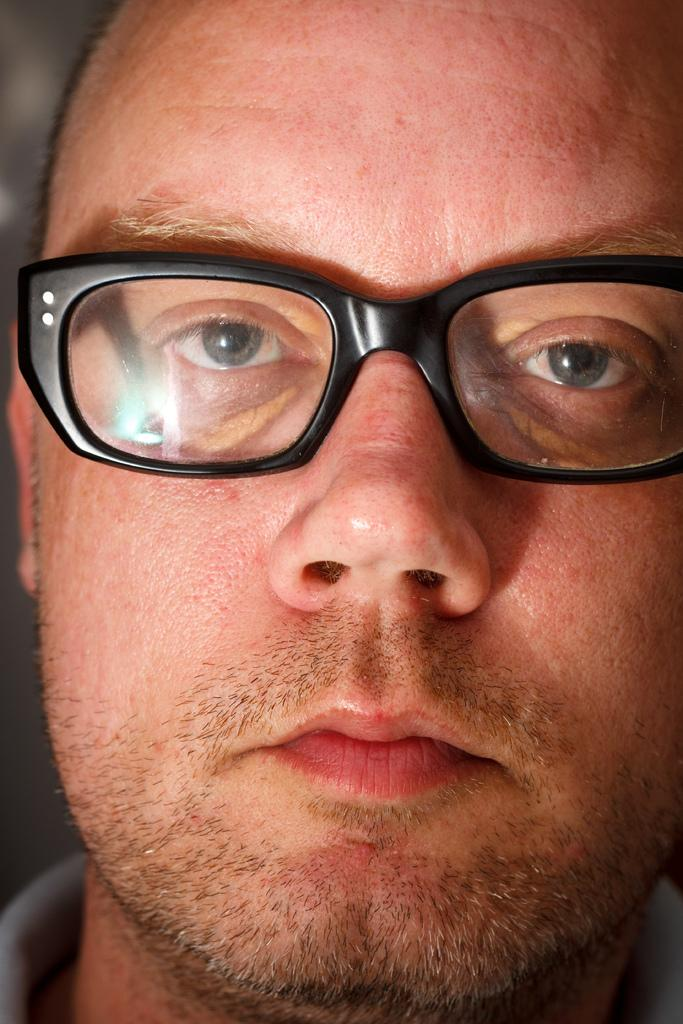What is the main subject of the image? There is a person in the image. What type of kite is the person flying in the image? There is no kite present in the image; it only features a person. How does the person use the yoke in the image? There is no yoke present in the image; it only features a person. 